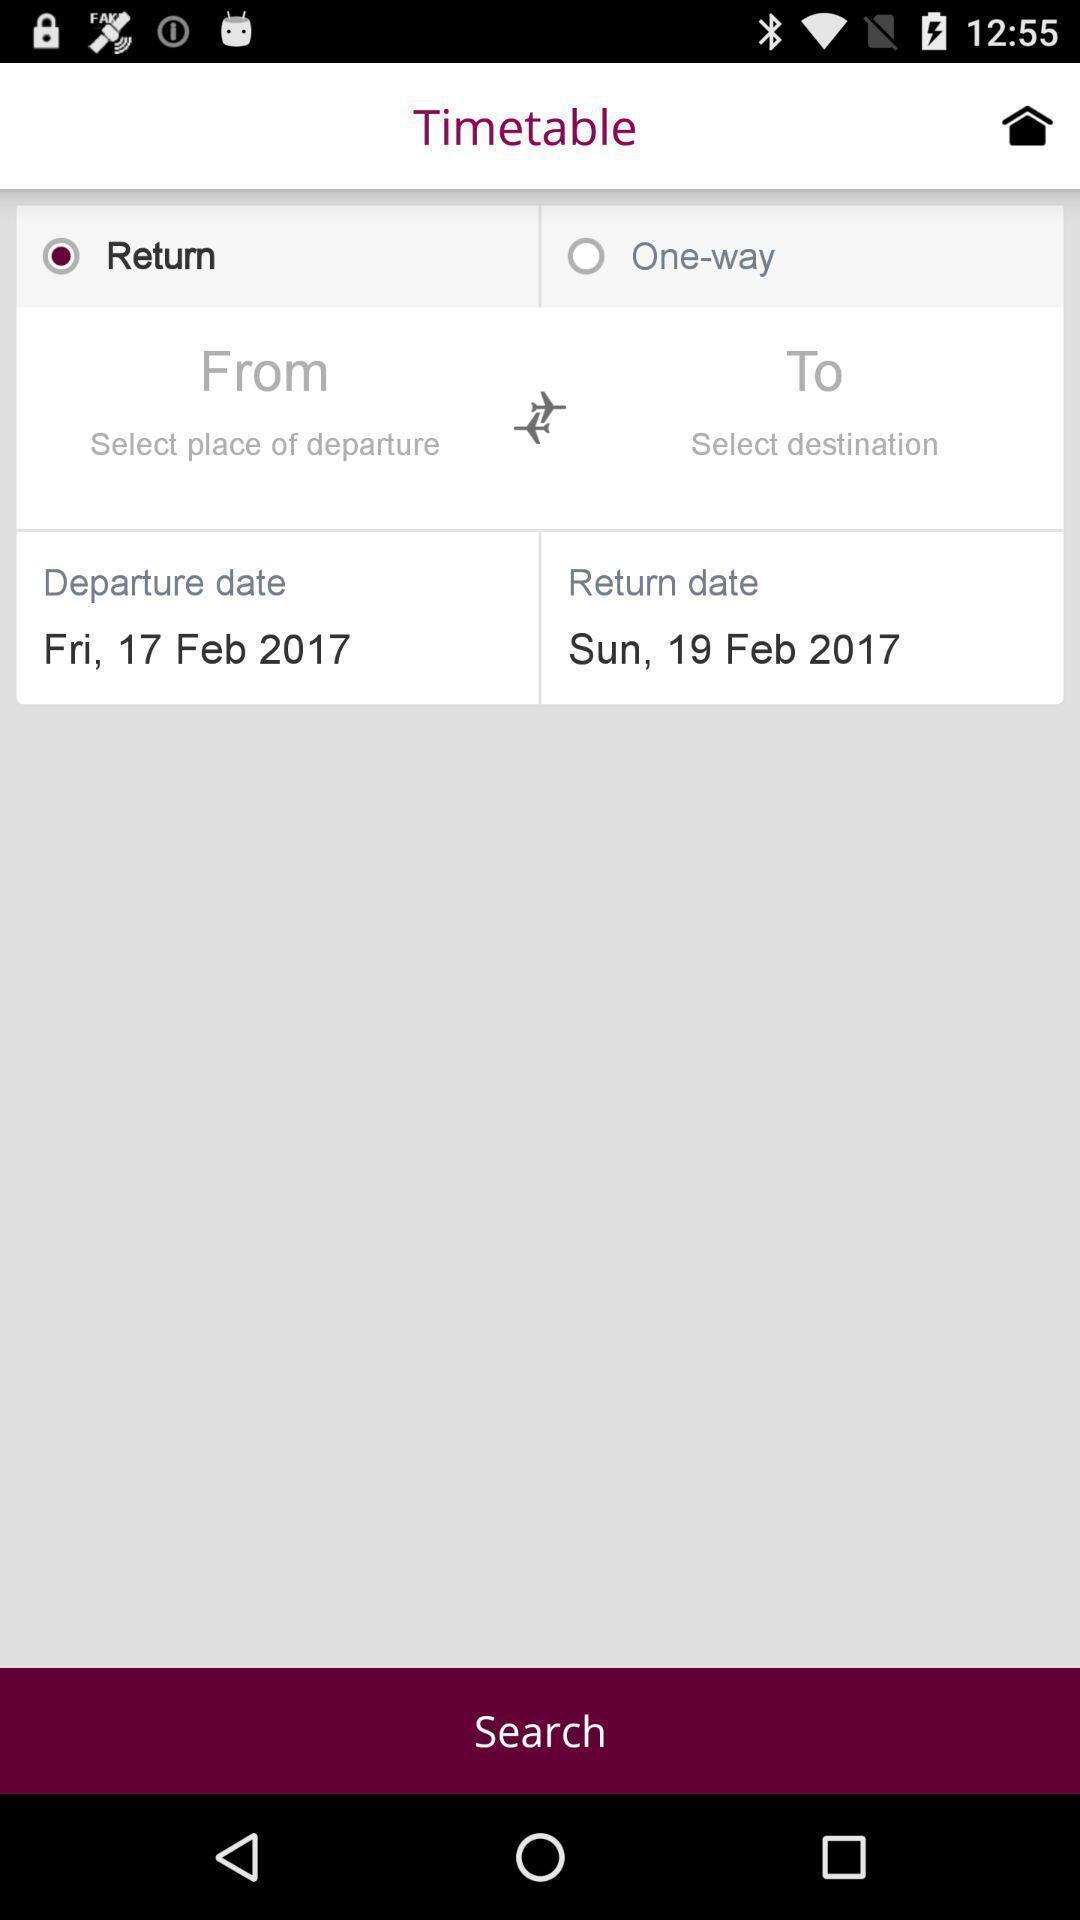What is the overall content of this screenshot? Page to search a flight. 